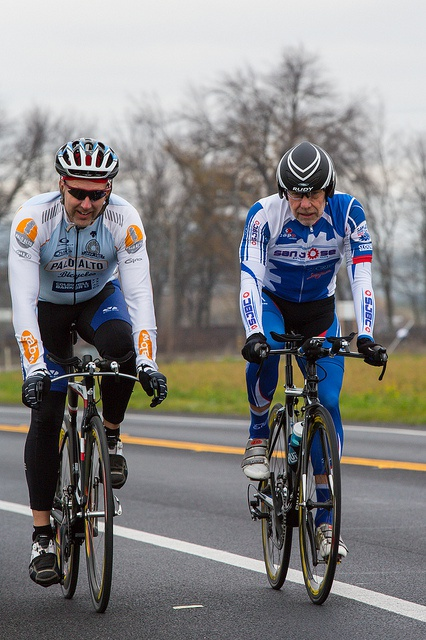Describe the objects in this image and their specific colors. I can see people in white, black, gray, navy, and darkgray tones, people in white, black, lavender, gray, and darkgray tones, bicycle in white, black, gray, darkgray, and navy tones, and bicycle in white, black, gray, darkgray, and maroon tones in this image. 